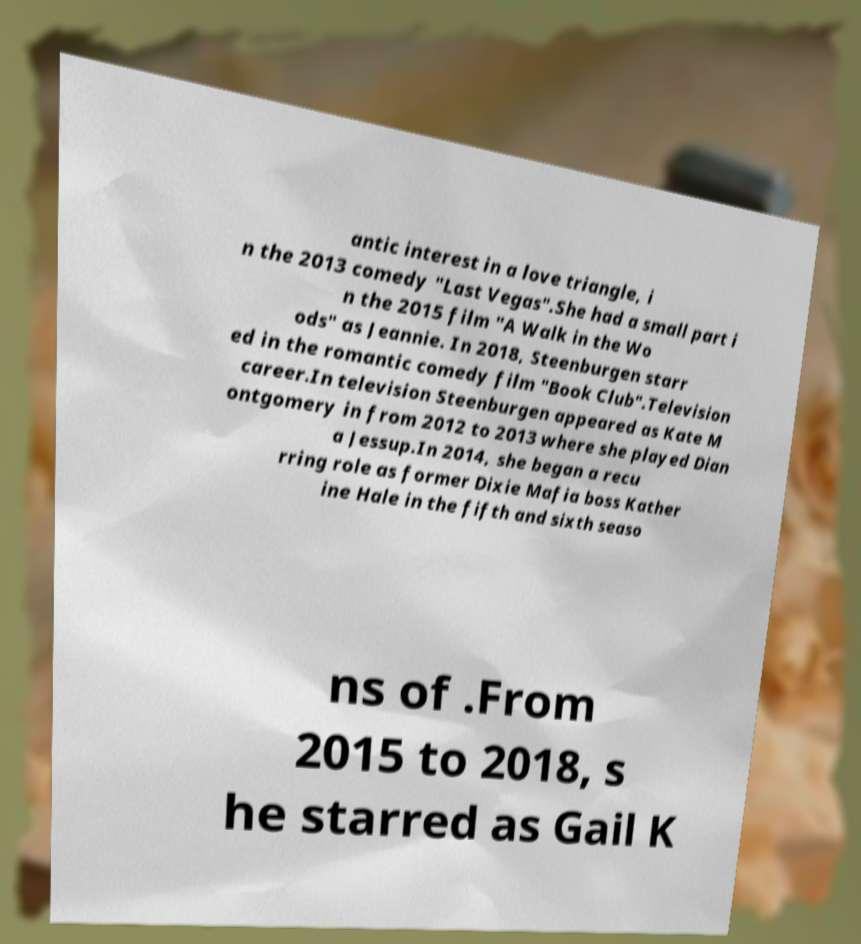Can you accurately transcribe the text from the provided image for me? antic interest in a love triangle, i n the 2013 comedy "Last Vegas".She had a small part i n the 2015 film "A Walk in the Wo ods" as Jeannie. In 2018, Steenburgen starr ed in the romantic comedy film "Book Club".Television career.In television Steenburgen appeared as Kate M ontgomery in from 2012 to 2013 where she played Dian a Jessup.In 2014, she began a recu rring role as former Dixie Mafia boss Kather ine Hale in the fifth and sixth seaso ns of .From 2015 to 2018, s he starred as Gail K 